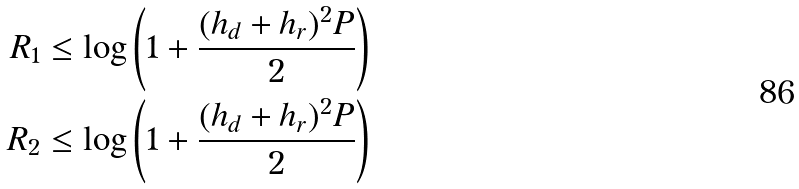Convert formula to latex. <formula><loc_0><loc_0><loc_500><loc_500>R _ { 1 } & \leq \log \left ( 1 + \frac { ( h _ { d } + h _ { r } ) ^ { 2 } P } { 2 } \right ) \\ R _ { 2 } & \leq \log \left ( 1 + \frac { ( h _ { d } + h _ { r } ) ^ { 2 } P } { 2 } \right )</formula> 